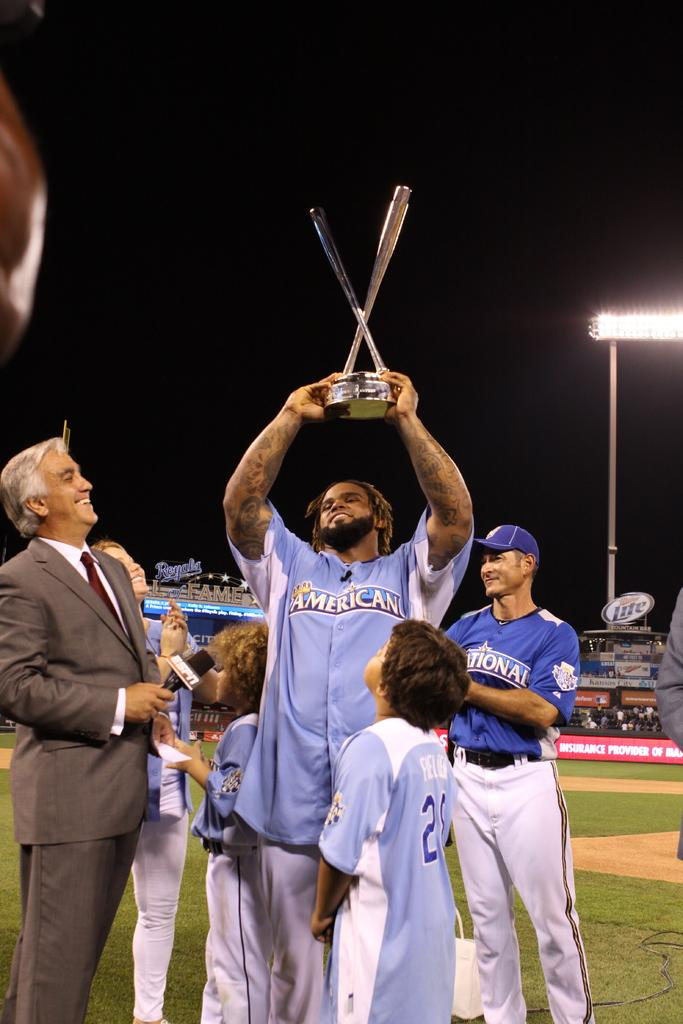Provide a one-sentence caption for the provided image. A man in a blue sports uniform with the logo for americano on his chest is holding up a trophy over his head. 